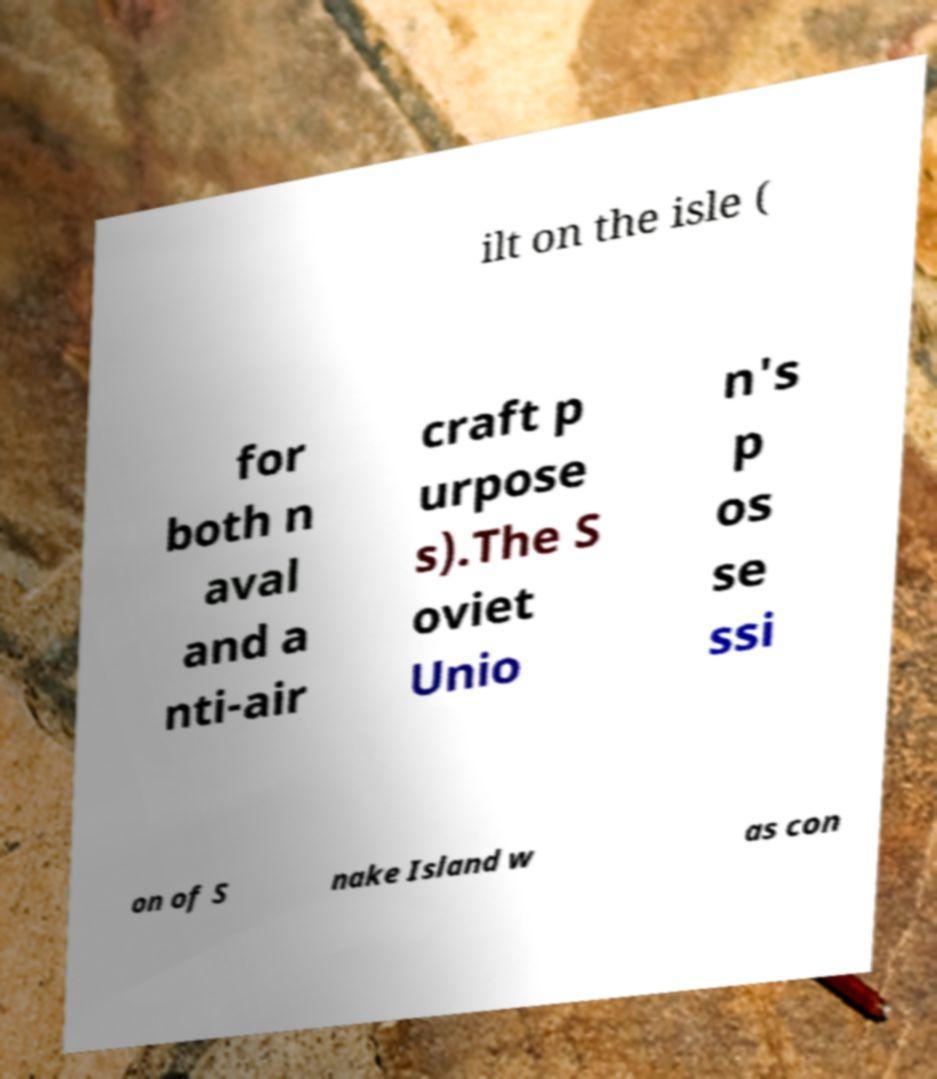For documentation purposes, I need the text within this image transcribed. Could you provide that? ilt on the isle ( for both n aval and a nti-air craft p urpose s).The S oviet Unio n's p os se ssi on of S nake Island w as con 